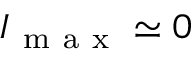Convert formula to latex. <formula><loc_0><loc_0><loc_500><loc_500>I _ { m a x } \simeq 0</formula> 